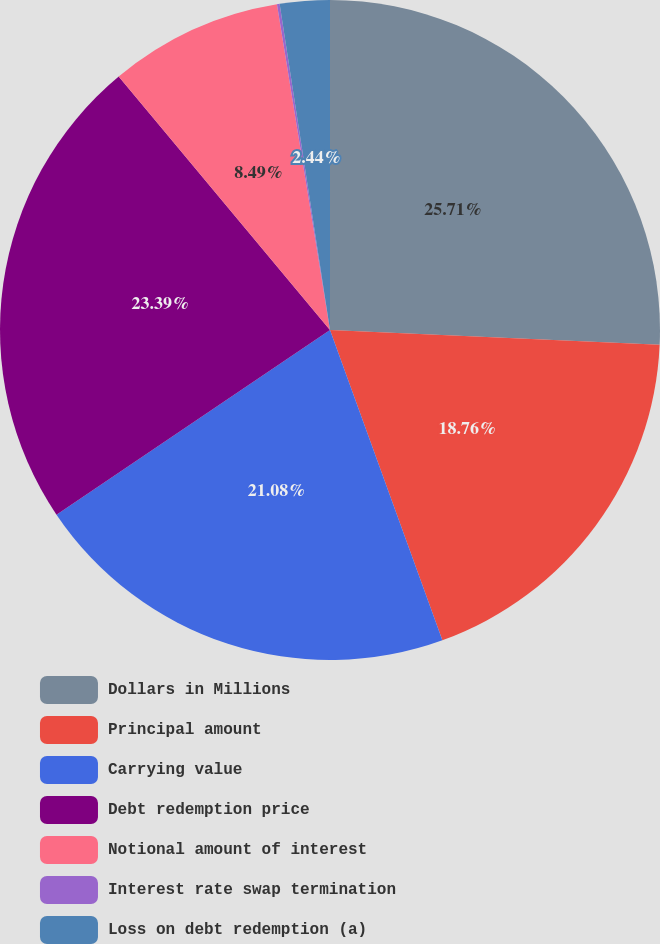Convert chart to OTSL. <chart><loc_0><loc_0><loc_500><loc_500><pie_chart><fcel>Dollars in Millions<fcel>Principal amount<fcel>Carrying value<fcel>Debt redemption price<fcel>Notional amount of interest<fcel>Interest rate swap termination<fcel>Loss on debt redemption (a)<nl><fcel>25.71%<fcel>18.76%<fcel>21.08%<fcel>23.39%<fcel>8.49%<fcel>0.13%<fcel>2.44%<nl></chart> 